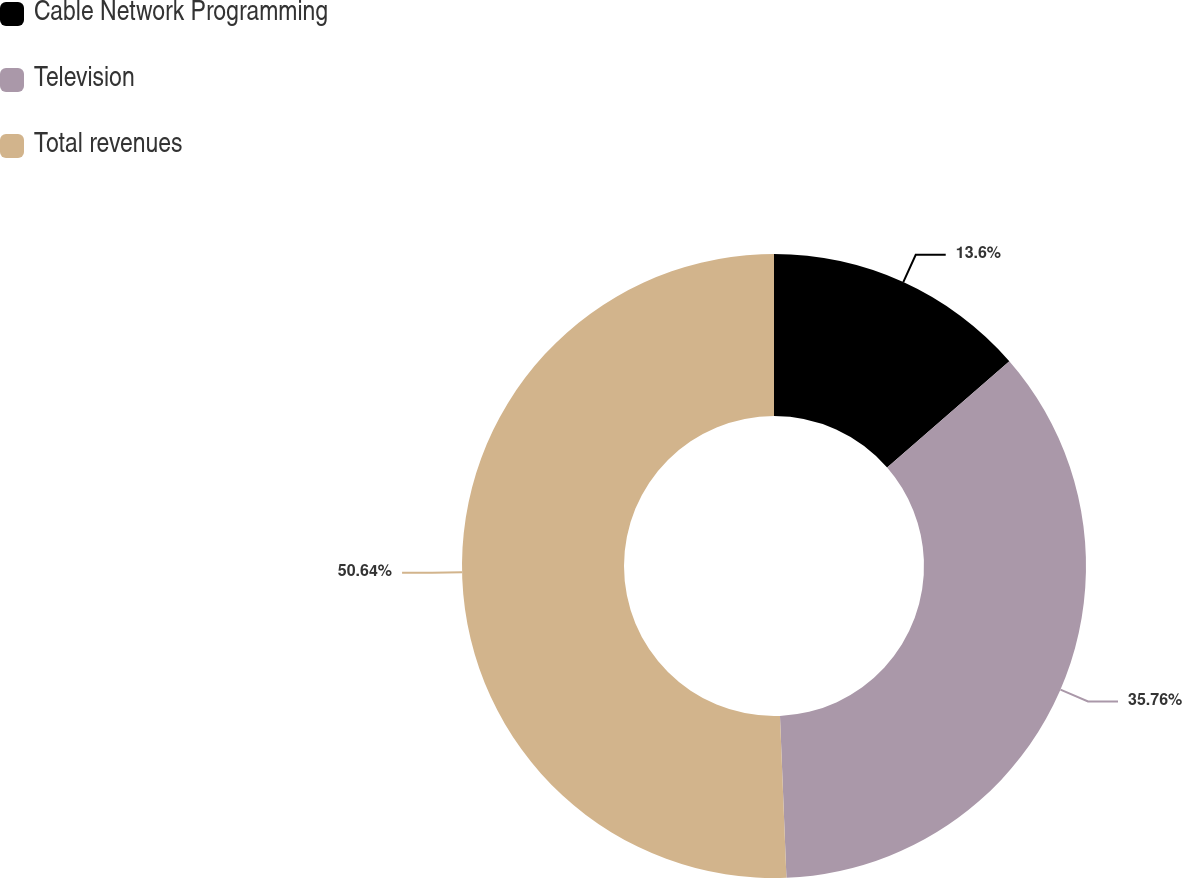Convert chart. <chart><loc_0><loc_0><loc_500><loc_500><pie_chart><fcel>Cable Network Programming<fcel>Television<fcel>Total revenues<nl><fcel>13.6%<fcel>35.76%<fcel>50.63%<nl></chart> 